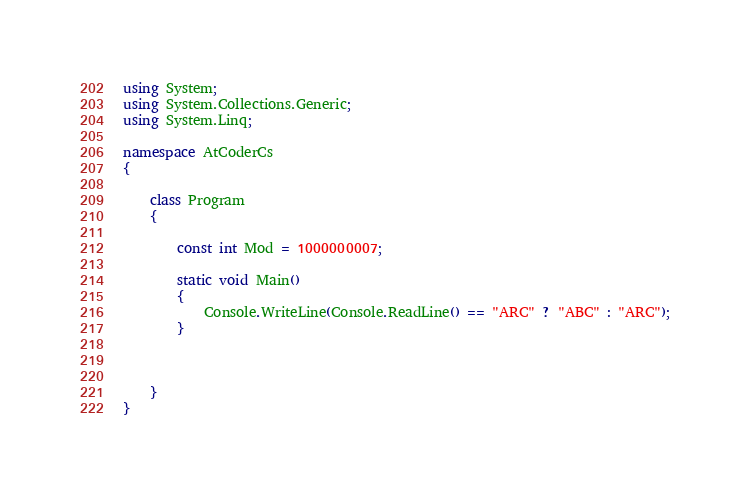<code> <loc_0><loc_0><loc_500><loc_500><_C#_>using System;
using System.Collections.Generic;
using System.Linq;

namespace AtCoderCs
{

    class Program
    {

        const int Mod = 1000000007;

        static void Main()
        {
            Console.WriteLine(Console.ReadLine() == "ARC" ? "ABC" : "ARC");
        }



    }
}
</code> 